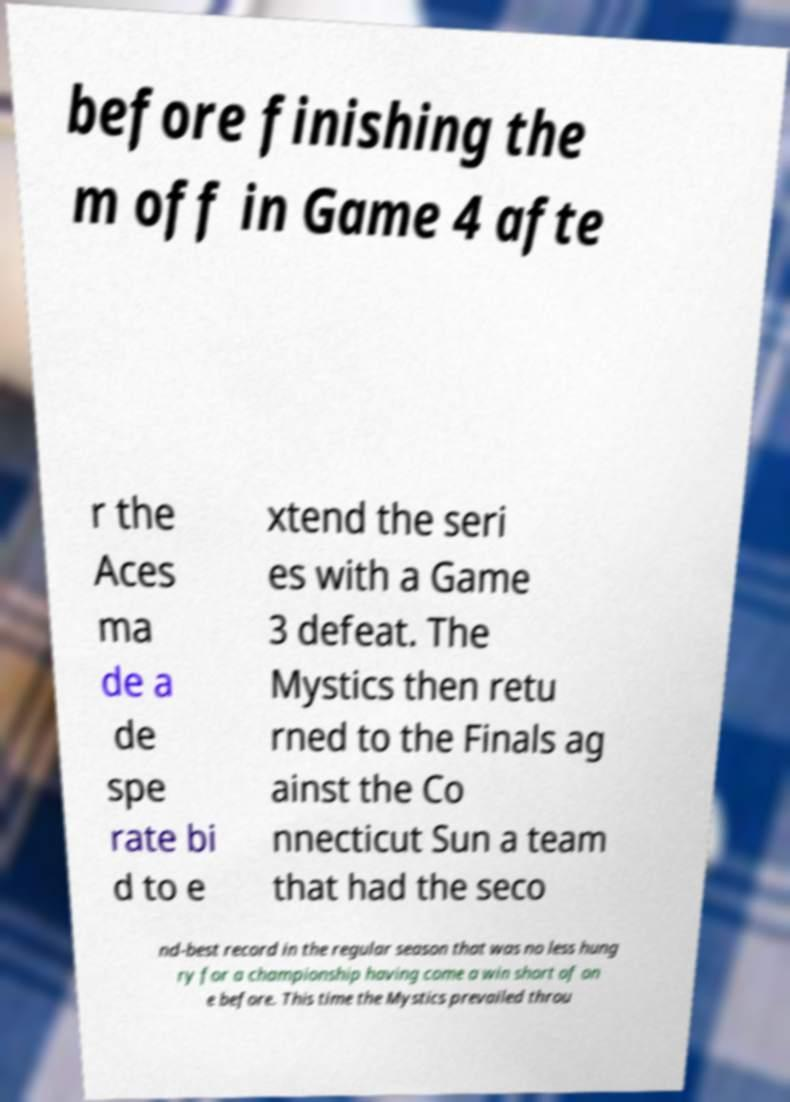I need the written content from this picture converted into text. Can you do that? before finishing the m off in Game 4 afte r the Aces ma de a de spe rate bi d to e xtend the seri es with a Game 3 defeat. The Mystics then retu rned to the Finals ag ainst the Co nnecticut Sun a team that had the seco nd-best record in the regular season that was no less hung ry for a championship having come a win short of on e before. This time the Mystics prevailed throu 